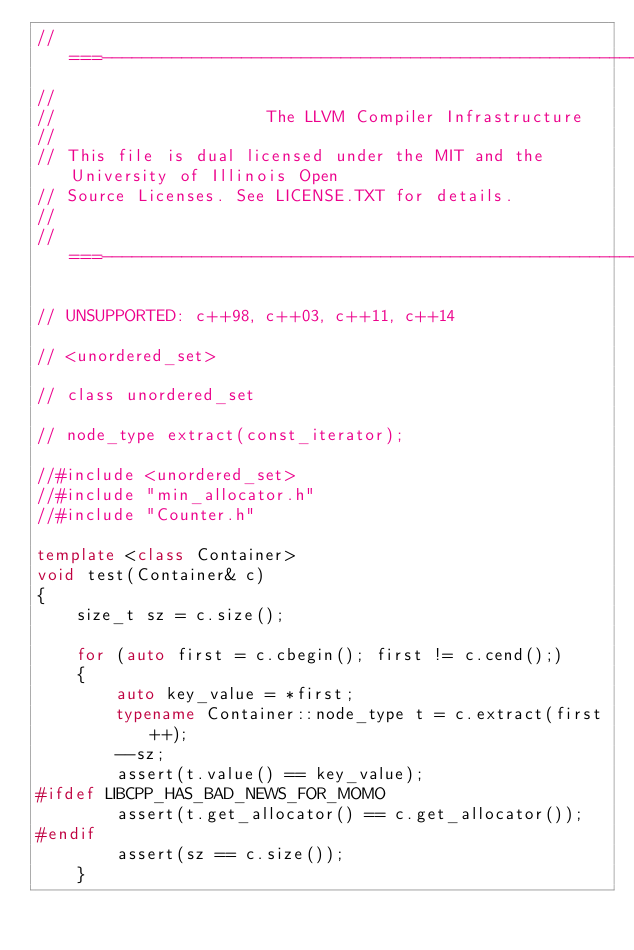<code> <loc_0><loc_0><loc_500><loc_500><_C++_>//===----------------------------------------------------------------------===//
//
//                     The LLVM Compiler Infrastructure
//
// This file is dual licensed under the MIT and the University of Illinois Open
// Source Licenses. See LICENSE.TXT for details.
//
//===----------------------------------------------------------------------===//

// UNSUPPORTED: c++98, c++03, c++11, c++14

// <unordered_set>

// class unordered_set

// node_type extract(const_iterator);

//#include <unordered_set>
//#include "min_allocator.h"
//#include "Counter.h"

template <class Container>
void test(Container& c)
{
    size_t sz = c.size();

    for (auto first = c.cbegin(); first != c.cend();)
    {
        auto key_value = *first;
        typename Container::node_type t = c.extract(first++);
        --sz;
        assert(t.value() == key_value);
#ifdef LIBCPP_HAS_BAD_NEWS_FOR_MOMO
        assert(t.get_allocator() == c.get_allocator());
#endif
        assert(sz == c.size());
    }
</code> 